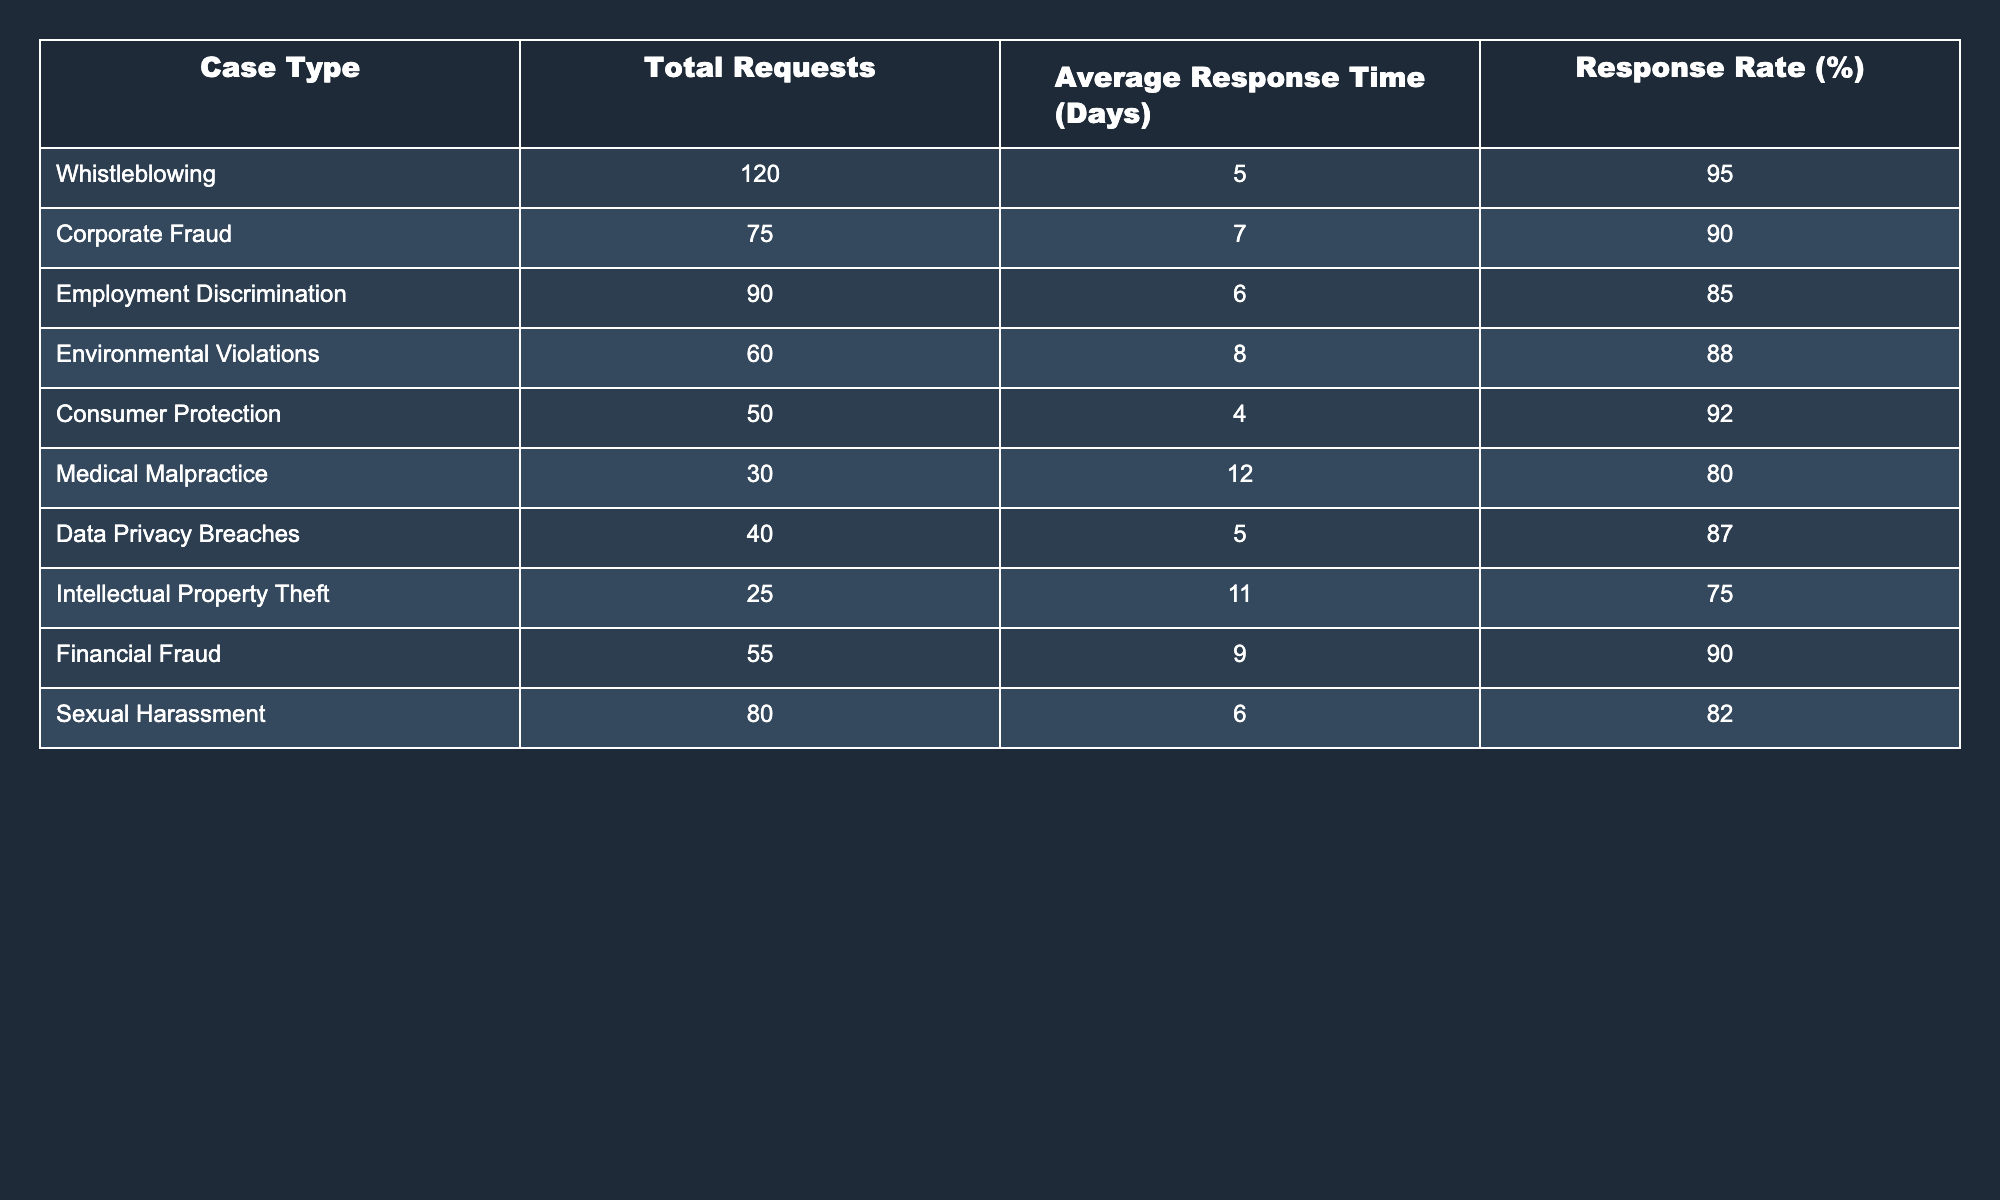What is the average response time for Employment Discrimination cases? The table shows that the average response time for Employment Discrimination is listed as 6 days. Therefore, this can be directly retrieved from the corresponding row in the table.
Answer: 6 days How many total requests were made for Consumer Protection cases? According to the table, the total requests made for Consumer Protection cases is explicitly stated as 50. This value can be found directly in the relevant cell of the table.
Answer: 50 Which case type has the highest response rate and what is that rate? By examining the Response Rate column, Whistleblowing has the highest response rate at 95%. It is the maximum value in that column when compared against others.
Answer: Whistleblowing, 95% What is the difference in average response time between Medical Malpractice and Corporate Fraud cases? From the table, we see that the average response time for Medical Malpractice is 12 days and for Corporate Fraud is 7 days. The difference is calculated as 12 - 7 = 5 days.
Answer: 5 days Is the response rate for Data Privacy Breaches greater than 85%? The response rate for Data Privacy Breaches, as per the table, is 87%. Since 87% is greater than 85%, the statement is true.
Answer: Yes Which case type has the lowest total requests, and what is the number of requests? Upon reviewing the Total Requests column, Intellectual Property Theft has the lowest total requests at 25. This number is the smallest value in that column.
Answer: Intellectual Property Theft, 25 What is the average response time for cases with a response rate below 80%? The table shows only Medical Malpractice with an average response time of 12 days and a response rate of 80%. No cases show a response rate below 80%, thus we have 0 cases to calculate an average. The average response time for below 80% case types is undefined.
Answer: Undefined How many case types have a response rate of 90% or higher? The table lists four case types—Whistleblowing, Corporate Fraud, Consumer Protection, and Financial Fraud—that all have response rates at or above 90%. By checking the Response Rate column, we can count these to find the total.
Answer: 4 If you sum the total requests for all case types, what is the total number? By adding up each of the Total Requests values from the table: 120 + 75 + 90 + 60 + 50 + 30 + 40 + 25 + 55 + 80, we find that the total requests equal 605. This simple addition gives the final number.
Answer: 605 